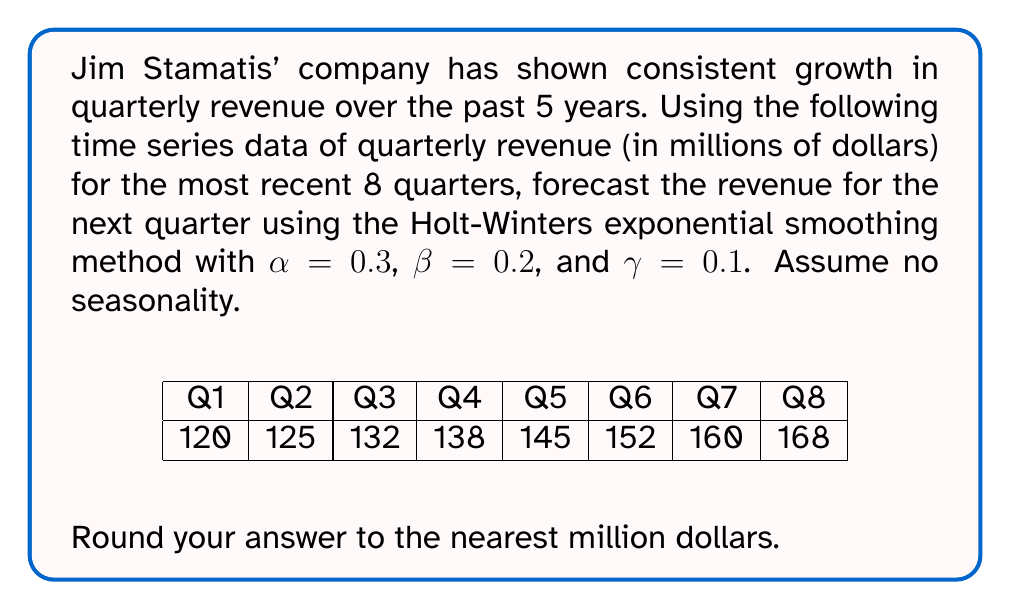Could you help me with this problem? To forecast the revenue for the next quarter using the Holt-Winters exponential smoothing method without seasonality (also known as double exponential smoothing), we'll follow these steps:

1. Initialize the level (L) and trend (T) components:
   $L_0 = 120$ (first observation)
   $T_0 = 125 - 120 = 5$ (difference between first two observations)

2. For each time period t, calculate the level and trend:
   $L_t = \alpha Y_t + (1-\alpha)(L_{t-1} + T_{t-1})$
   $T_t = \beta(L_t - L_{t-1}) + (1-\beta)T_{t-1}$

   Where:
   $Y_t$ is the observed value at time t
   $\alpha$ is the level smoothing factor (0.3)
   $\beta$ is the trend smoothing factor (0.2)

3. Calculate the forecast for the next period:
   $F_{t+1} = L_t + T_t$

Let's calculate for each quarter:

Q1: $L_1 = 120$, $T_1 = 5$
Q2: $L_2 = 0.3(125) + 0.7(120+5) = 125.25$, $T_2 = 0.2(125.25-120) + 0.8(5) = 5.05$
Q3: $L_3 = 0.3(132) + 0.7(125.25+5.05) = 131.61$, $T_3 = 0.2(131.61-125.25) + 0.8(5.05) = 5.32$
Q4: $L_4 = 0.3(138) + 0.7(131.61+5.32) = 137.95$, $T_4 = 0.2(137.95-131.61) + 0.8(5.32) = 5.55$
Q5: $L_5 = 0.3(145) + 0.7(137.95+5.55) = 144.55$, $T_5 = 0.2(144.55-137.95) + 0.8(5.55) = 5.84$
Q6: $L_6 = 0.3(152) + 0.7(144.55+5.84) = 151.47$, $T_6 = 0.2(151.47-144.55) + 0.8(5.84) = 6.17$
Q7: $L_7 = 0.3(160) + 0.7(151.47+6.17) = 158.75$, $T_7 = 0.2(158.75-151.47) + 0.8(6.17) = 6.54$
Q8: $L_8 = 0.3(168) + 0.7(158.75+6.54) = 166.40$, $T_8 = 0.2(166.40-158.75) + 0.8(6.54) = 6.95$

4. Forecast for Q9:
   $F_9 = L_8 + T_8 = 166.40 + 6.95 = 173.35$

5. Rounding to the nearest million:
   $173.35 \approx 173$ million dollars
Answer: $173 million 